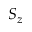Convert formula to latex. <formula><loc_0><loc_0><loc_500><loc_500>S _ { z }</formula> 